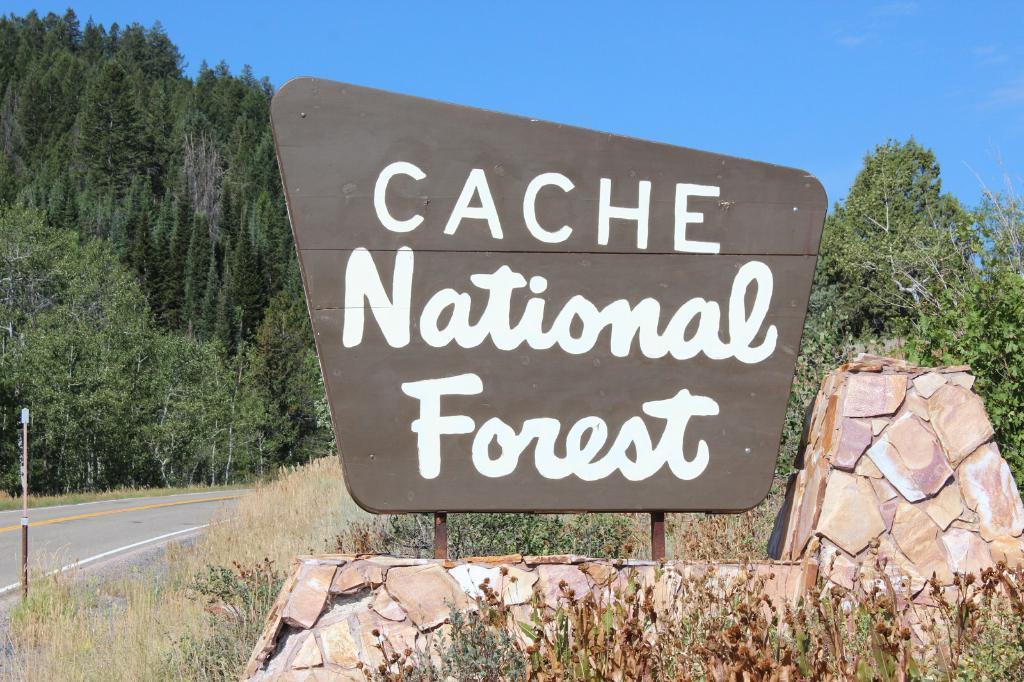In one or two sentences, can you explain what this image depicts? This image consists of a board, fence, grass, pole, trees and the sky. This image is taken may be during a day. 